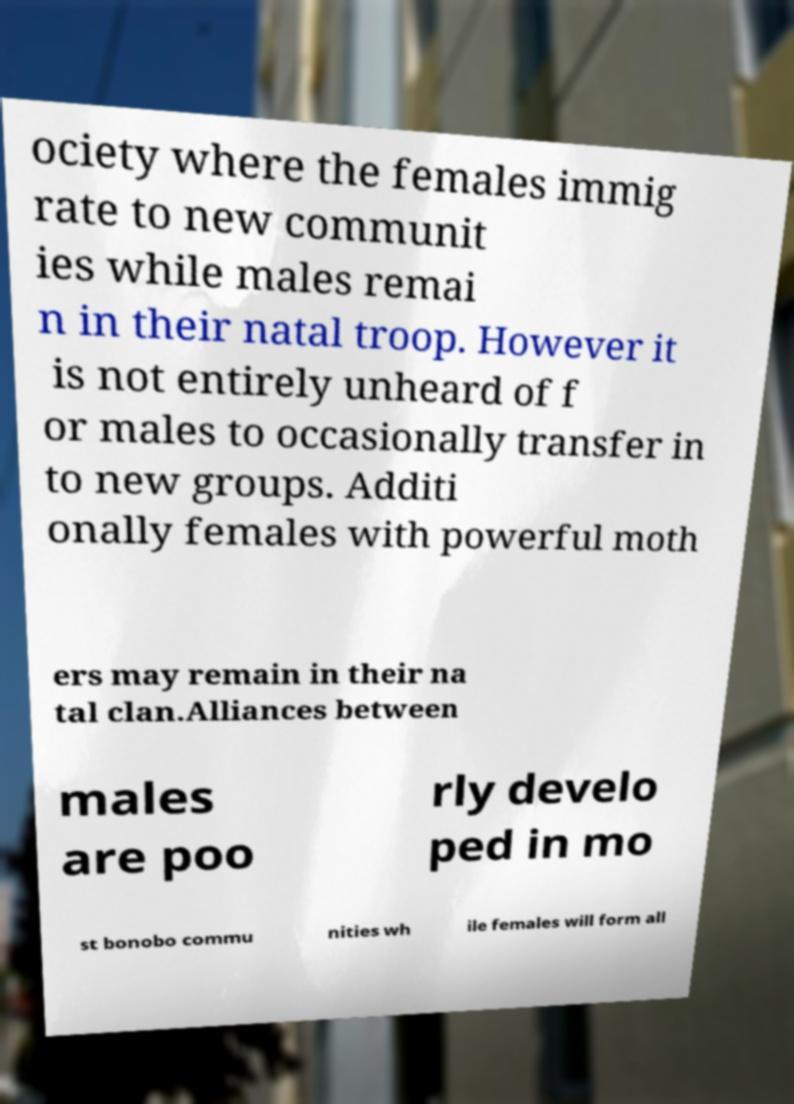Please identify and transcribe the text found in this image. ociety where the females immig rate to new communit ies while males remai n in their natal troop. However it is not entirely unheard of f or males to occasionally transfer in to new groups. Additi onally females with powerful moth ers may remain in their na tal clan.Alliances between males are poo rly develo ped in mo st bonobo commu nities wh ile females will form all 